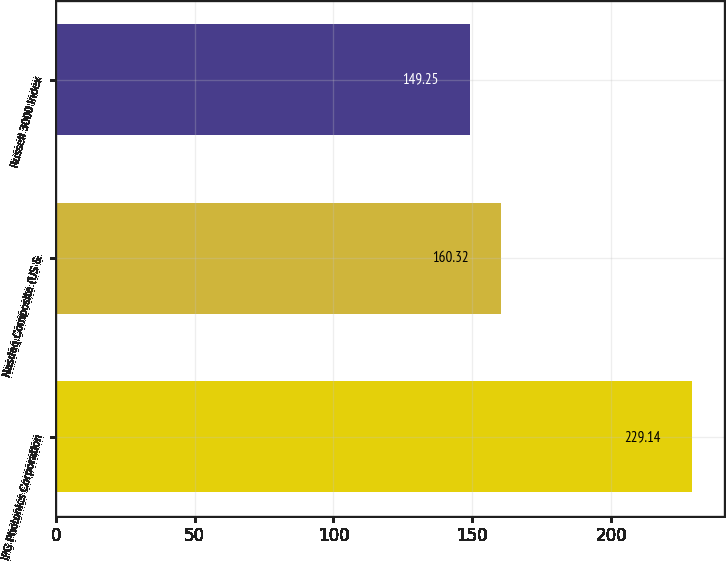Convert chart. <chart><loc_0><loc_0><loc_500><loc_500><bar_chart><fcel>IPG Photonics Corporation<fcel>Nasdaq Composite (US &<fcel>Russell 3000 Index<nl><fcel>229.14<fcel>160.32<fcel>149.25<nl></chart> 